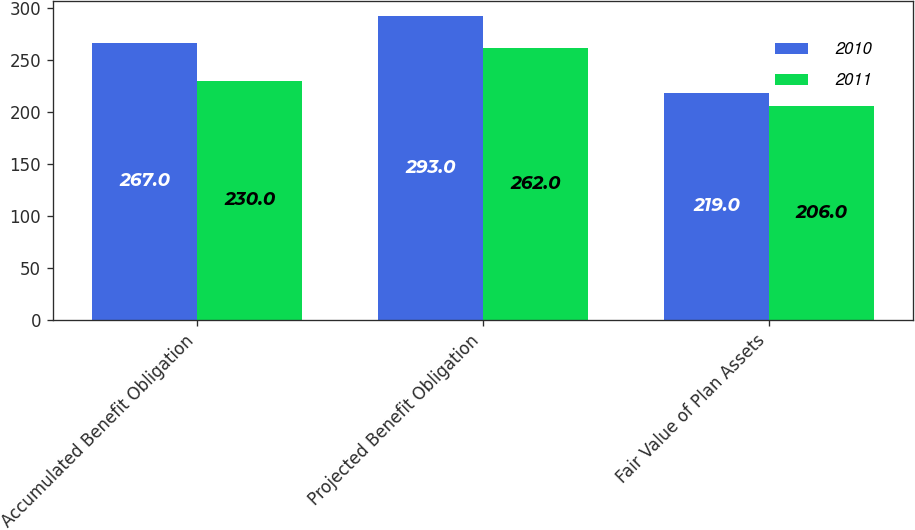<chart> <loc_0><loc_0><loc_500><loc_500><stacked_bar_chart><ecel><fcel>Accumulated Benefit Obligation<fcel>Projected Benefit Obligation<fcel>Fair Value of Plan Assets<nl><fcel>2010<fcel>267<fcel>293<fcel>219<nl><fcel>2011<fcel>230<fcel>262<fcel>206<nl></chart> 